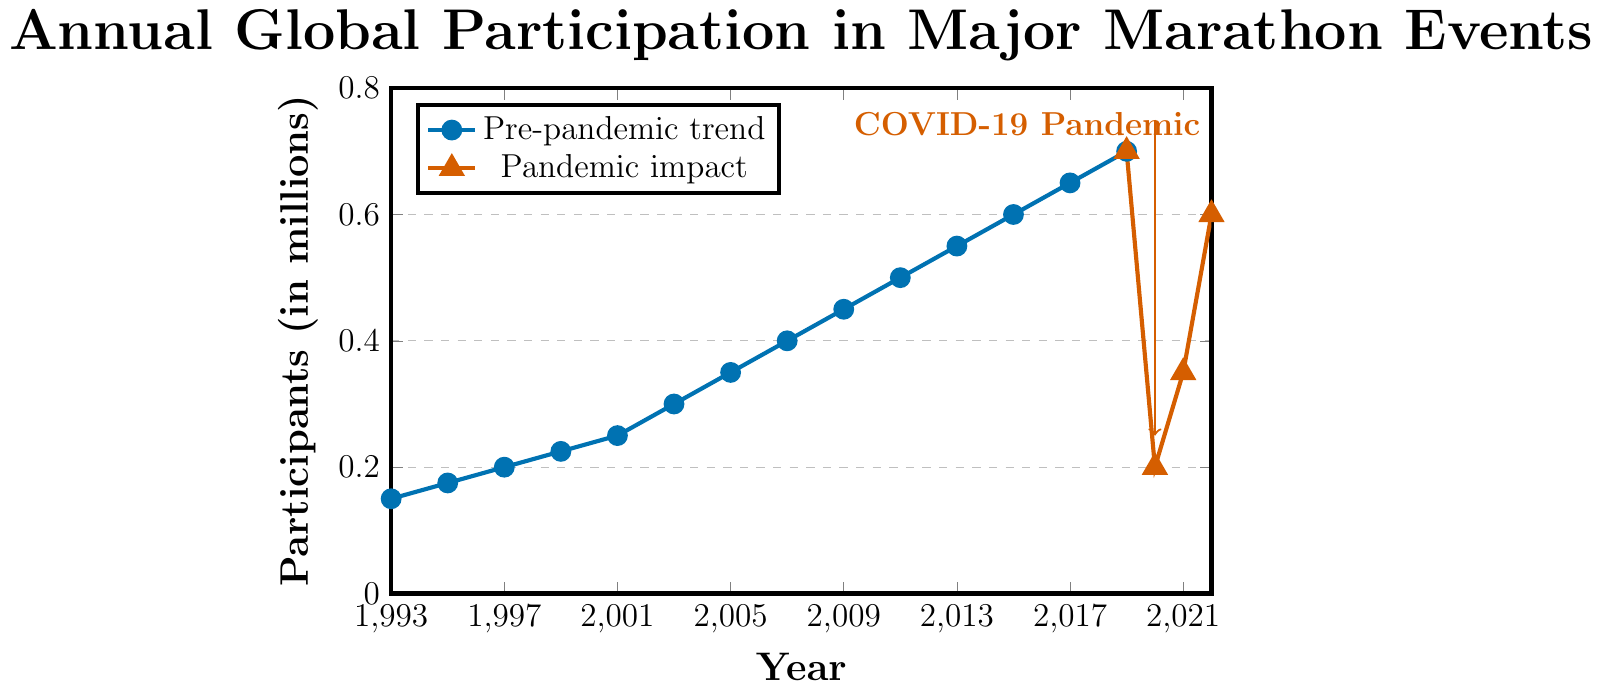What trend is observed in marathon participation from 1993 to 2019? From 1993 to 2019, the number of participants in major marathons shows a consistent upward trend. The data points and the increasing slope of the blue line indicate that participation grew steadily, starting from 150,000 in 1993 to 700,000 in 2019.
Answer: Increasing Trend What was the impact of the COVID-19 pandemic on marathon participation in 2020? The red line section of the plot shows a significant drop in participation in 2020. Participation decreased from 700,000 to 200,000, indicating the pandemic's heavy impact on marathon events that year.
Answer: Decreased How does the number of participants in 2021 compare to that in 2020? In 2021, the number of participants increased to 350,000 from 200,000 in 2020. The increase is visually indicated by the red line moving upward from 2020 to 2021.
Answer: Increased Which year shows the highest participation in the pre-pandemic trend, and what was the value? The highest participation in the pre-pandemic trend occurred in 2019, with a value of 700,000 participants, as indicated by the peak of the blue line before the red line segment.
Answer: 2019, 700,000 What is the average number of participants from 1993 to 2019? To find the average, sum the participant numbers from 1993 to 2019 and divide by the number of years. (150,000 + 175,000 + 200,000 + 225,000 + 250,000 + 300,000 + 350,000 + 400,000 + 450,000 + 500,000 + 550,000 + 600,000 + 650,000 + 700,000) / 14 = 475,000.
Answer: 475,000 What was the change in participants between 2019 and 2022? In 2019, there were 700,000 participants, and in 2022, there were 600,000 participants. The change is found by subtracting the 2022 value from the 2019 value: 700,000 - 600,000 = 100,000.
Answer: Decreased by 100,000 Between which consecutive years did the largest increase in participants occur pre-pandemic? The largest increase can be seen between 2011 and 2013, moving from 500,000 to 550,000. The increase is 50,000 participants, as indicated by the steepest segment in the blue line.
Answer: Between 2011 and 2013 What visual indication is used to highlight the COVID-19 pandemic's impact on the graph? A red annotation labeled "COVID-19 Pandemic" is placed near the drop, and a thick red arrow points downward from 2020, emphasizing the drastic reduction in participation.
Answer: Red arrow and annotation How did marathon participation recover from 2020 to 2022? After the drastic drop in 2020 to 200,000 participants, numbers increased to 350,000 in 2021 and further rose to 600,000 in 2022. This recovery is depicted by the red line trending upward through these years.
Answer: Recovery from 200,000 to 600,000 